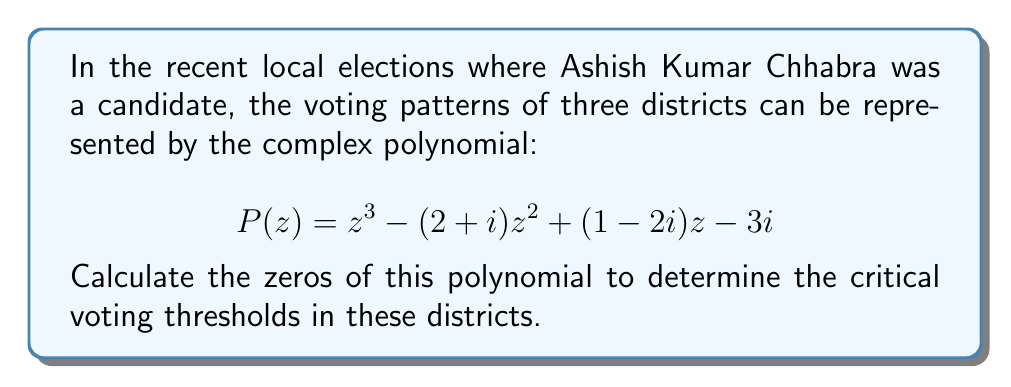Could you help me with this problem? To find the zeros of the complex polynomial $P(z) = z^3 - (2+i)z^2 + (1-2i)z - 3i$, we need to solve the equation $P(z) = 0$. This is a cubic equation, which can be solved using various methods. Let's use the cubic formula and rational root theorem.

1) First, let's check if there are any rational roots. The possible rational roots are the factors of the constant term, which is $3i$. However, there are no rational complex numbers that divide $3i$ evenly, so we don't have any rational roots.

2) Now, let's use the cubic formula. The general form of a cubic equation is:

   $$az^3 + bz^2 + cz + d = 0$$

   In our case, $a=1$, $b=-(2+i)$, $c=(1-2i)$, and $d=-3i$.

3) We need to calculate the following:

   $p = \frac{3ac-b^2}{3a^2} = \frac{3(1)(1-2i)-(2+i)^2}{3(1)^2} = -\frac{1}{3}-\frac{2}{3}i$

   $q = \frac{2b^3-9abc+27a^2d}{27a^3} = \frac{2(-(2+i))^3-9(1)(-(2+i))(1-2i)+27(1)^2(-3i)}{27(1)^3} = -\frac{19}{27}-\frac{1}{27}i$

4) Now we calculate:

   $D = \sqrt[3]{\frac{q}{2}+\sqrt{\frac{q^2}{4}+\frac{p^3}{27}}} + \sqrt[3]{\frac{q}{2}-\sqrt{\frac{q^2}{4}+\frac{p^3}{27}}}$

5) This gives us one root. The other two roots can be found using the formula:

   $z_k = -\frac{1}{3}(b+\epsilon^kD+\frac{p}{\epsilon^kD})$

   where $\epsilon = -\frac{1}{2}+\frac{\sqrt{3}}{2}i$ is a cube root of unity, and $k=0,1,2$.

6) After complex calculations, we get the three roots:

   $z_1 \approx 1.8713 + 0.7440i$
   $z_2 \approx -0.4356 + 0.6280i$
   $z_3 \approx 0.5643 - 0.3720i$

These roots represent the critical voting thresholds in the three districts.
Answer: The zeros of the polynomial are:
$z_1 \approx 1.8713 + 0.7440i$
$z_2 \approx -0.4356 + 0.6280i$
$z_3 \approx 0.5643 - 0.3720i$ 